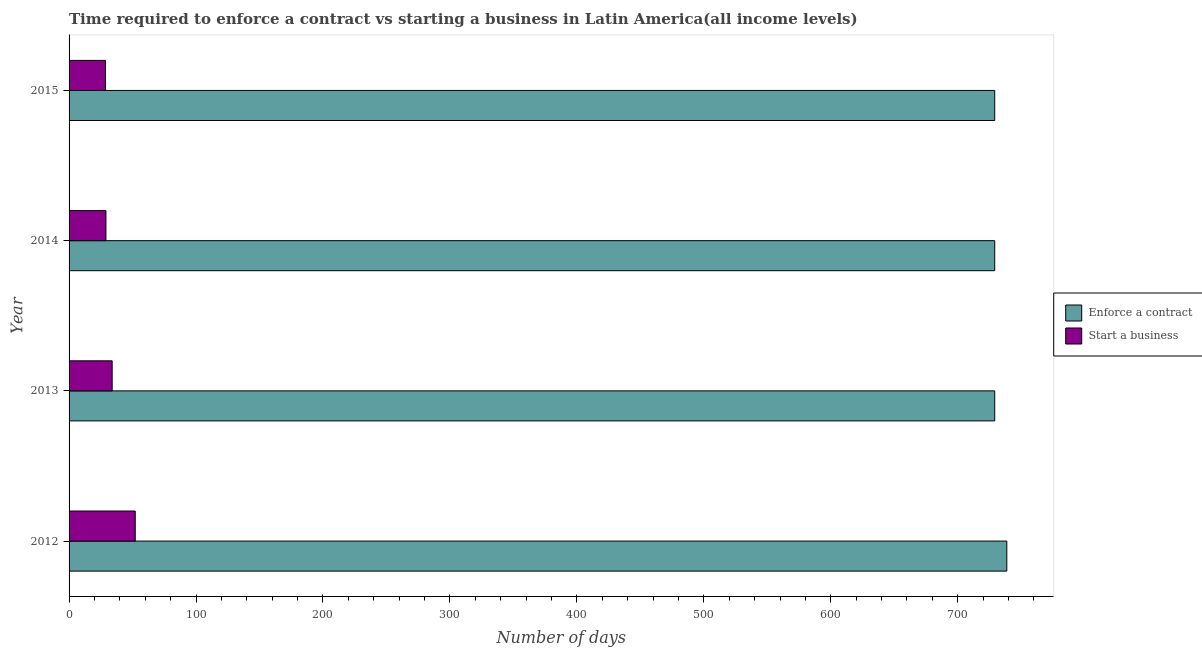Are the number of bars per tick equal to the number of legend labels?
Keep it short and to the point. Yes. Are the number of bars on each tick of the Y-axis equal?
Ensure brevity in your answer.  Yes. How many bars are there on the 2nd tick from the top?
Your answer should be compact. 2. How many bars are there on the 2nd tick from the bottom?
Provide a succinct answer. 2. What is the label of the 3rd group of bars from the top?
Your response must be concise. 2013. In how many cases, is the number of bars for a given year not equal to the number of legend labels?
Your answer should be very brief. 0. What is the number of days to enforece a contract in 2012?
Provide a succinct answer. 738.65. Across all years, what is the maximum number of days to start a business?
Make the answer very short. 52.11. Across all years, what is the minimum number of days to enforece a contract?
Offer a terse response. 729.12. In which year was the number of days to start a business minimum?
Give a very brief answer. 2015. What is the total number of days to start a business in the graph?
Your answer should be compact. 143.77. What is the difference between the number of days to start a business in 2013 and that in 2014?
Your answer should be very brief. 4.91. What is the difference between the number of days to start a business in 2014 and the number of days to enforece a contract in 2013?
Your response must be concise. -700.08. What is the average number of days to start a business per year?
Provide a short and direct response. 35.94. In the year 2012, what is the difference between the number of days to start a business and number of days to enforece a contract?
Provide a short and direct response. -686.53. In how many years, is the number of days to start a business greater than 360 days?
Provide a short and direct response. 0. Is the difference between the number of days to start a business in 2014 and 2015 greater than the difference between the number of days to enforece a contract in 2014 and 2015?
Offer a very short reply. Yes. What is the difference between the highest and the second highest number of days to start a business?
Give a very brief answer. 18.16. What is the difference between the highest and the lowest number of days to start a business?
Provide a succinct answer. 23.45. In how many years, is the number of days to start a business greater than the average number of days to start a business taken over all years?
Your answer should be very brief. 1. What does the 2nd bar from the top in 2015 represents?
Offer a very short reply. Enforce a contract. What does the 1st bar from the bottom in 2012 represents?
Ensure brevity in your answer.  Enforce a contract. Are all the bars in the graph horizontal?
Make the answer very short. Yes. Are the values on the major ticks of X-axis written in scientific E-notation?
Your answer should be compact. No. Does the graph contain grids?
Keep it short and to the point. No. How are the legend labels stacked?
Your answer should be compact. Vertical. What is the title of the graph?
Ensure brevity in your answer.  Time required to enforce a contract vs starting a business in Latin America(all income levels). What is the label or title of the X-axis?
Keep it short and to the point. Number of days. What is the Number of days in Enforce a contract in 2012?
Your answer should be very brief. 738.65. What is the Number of days of Start a business in 2012?
Make the answer very short. 52.11. What is the Number of days of Enforce a contract in 2013?
Ensure brevity in your answer.  729.12. What is the Number of days in Start a business in 2013?
Provide a succinct answer. 33.95. What is the Number of days of Enforce a contract in 2014?
Provide a succinct answer. 729.12. What is the Number of days of Start a business in 2014?
Give a very brief answer. 29.04. What is the Number of days in Enforce a contract in 2015?
Your answer should be very brief. 729.12. What is the Number of days of Start a business in 2015?
Make the answer very short. 28.66. Across all years, what is the maximum Number of days of Enforce a contract?
Keep it short and to the point. 738.65. Across all years, what is the maximum Number of days of Start a business?
Provide a short and direct response. 52.11. Across all years, what is the minimum Number of days in Enforce a contract?
Your answer should be compact. 729.12. Across all years, what is the minimum Number of days in Start a business?
Your answer should be compact. 28.66. What is the total Number of days of Enforce a contract in the graph?
Provide a succinct answer. 2926.01. What is the total Number of days in Start a business in the graph?
Make the answer very short. 143.77. What is the difference between the Number of days of Enforce a contract in 2012 and that in 2013?
Your response must be concise. 9.52. What is the difference between the Number of days of Start a business in 2012 and that in 2013?
Your answer should be compact. 18.16. What is the difference between the Number of days of Enforce a contract in 2012 and that in 2014?
Provide a short and direct response. 9.52. What is the difference between the Number of days in Start a business in 2012 and that in 2014?
Provide a succinct answer. 23.07. What is the difference between the Number of days in Enforce a contract in 2012 and that in 2015?
Ensure brevity in your answer.  9.52. What is the difference between the Number of days in Start a business in 2012 and that in 2015?
Your answer should be very brief. 23.45. What is the difference between the Number of days of Start a business in 2013 and that in 2014?
Your answer should be compact. 4.91. What is the difference between the Number of days in Enforce a contract in 2013 and that in 2015?
Provide a short and direct response. 0. What is the difference between the Number of days in Start a business in 2013 and that in 2015?
Keep it short and to the point. 5.29. What is the difference between the Number of days in Start a business in 2014 and that in 2015?
Ensure brevity in your answer.  0.38. What is the difference between the Number of days of Enforce a contract in 2012 and the Number of days of Start a business in 2013?
Keep it short and to the point. 704.69. What is the difference between the Number of days in Enforce a contract in 2012 and the Number of days in Start a business in 2014?
Offer a very short reply. 709.6. What is the difference between the Number of days of Enforce a contract in 2012 and the Number of days of Start a business in 2015?
Give a very brief answer. 709.98. What is the difference between the Number of days in Enforce a contract in 2013 and the Number of days in Start a business in 2014?
Your response must be concise. 700.08. What is the difference between the Number of days in Enforce a contract in 2013 and the Number of days in Start a business in 2015?
Offer a very short reply. 700.46. What is the difference between the Number of days of Enforce a contract in 2014 and the Number of days of Start a business in 2015?
Your response must be concise. 700.46. What is the average Number of days of Enforce a contract per year?
Offer a very short reply. 731.5. What is the average Number of days of Start a business per year?
Make the answer very short. 35.94. In the year 2012, what is the difference between the Number of days in Enforce a contract and Number of days in Start a business?
Your response must be concise. 686.53. In the year 2013, what is the difference between the Number of days of Enforce a contract and Number of days of Start a business?
Make the answer very short. 695.17. In the year 2014, what is the difference between the Number of days in Enforce a contract and Number of days in Start a business?
Offer a very short reply. 700.08. In the year 2015, what is the difference between the Number of days in Enforce a contract and Number of days in Start a business?
Your response must be concise. 700.46. What is the ratio of the Number of days of Enforce a contract in 2012 to that in 2013?
Provide a short and direct response. 1.01. What is the ratio of the Number of days of Start a business in 2012 to that in 2013?
Your answer should be very brief. 1.53. What is the ratio of the Number of days of Enforce a contract in 2012 to that in 2014?
Your answer should be compact. 1.01. What is the ratio of the Number of days in Start a business in 2012 to that in 2014?
Provide a short and direct response. 1.79. What is the ratio of the Number of days in Enforce a contract in 2012 to that in 2015?
Ensure brevity in your answer.  1.01. What is the ratio of the Number of days in Start a business in 2012 to that in 2015?
Ensure brevity in your answer.  1.82. What is the ratio of the Number of days of Enforce a contract in 2013 to that in 2014?
Your answer should be compact. 1. What is the ratio of the Number of days in Start a business in 2013 to that in 2014?
Your response must be concise. 1.17. What is the ratio of the Number of days of Enforce a contract in 2013 to that in 2015?
Keep it short and to the point. 1. What is the ratio of the Number of days in Start a business in 2013 to that in 2015?
Provide a short and direct response. 1.18. What is the ratio of the Number of days in Enforce a contract in 2014 to that in 2015?
Your answer should be very brief. 1. What is the ratio of the Number of days of Start a business in 2014 to that in 2015?
Keep it short and to the point. 1.01. What is the difference between the highest and the second highest Number of days of Enforce a contract?
Keep it short and to the point. 9.52. What is the difference between the highest and the second highest Number of days of Start a business?
Make the answer very short. 18.16. What is the difference between the highest and the lowest Number of days of Enforce a contract?
Make the answer very short. 9.52. What is the difference between the highest and the lowest Number of days in Start a business?
Keep it short and to the point. 23.45. 